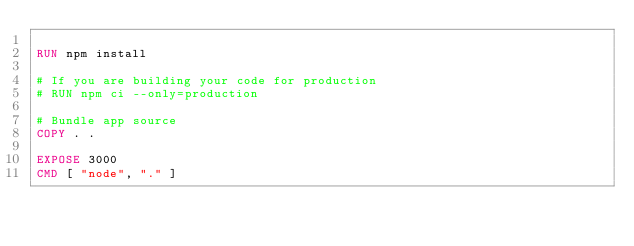Convert code to text. <code><loc_0><loc_0><loc_500><loc_500><_Dockerfile_>
RUN npm install

# If you are building your code for production
# RUN npm ci --only=production

# Bundle app source
COPY . .

EXPOSE 3000
CMD [ "node", "." ]</code> 